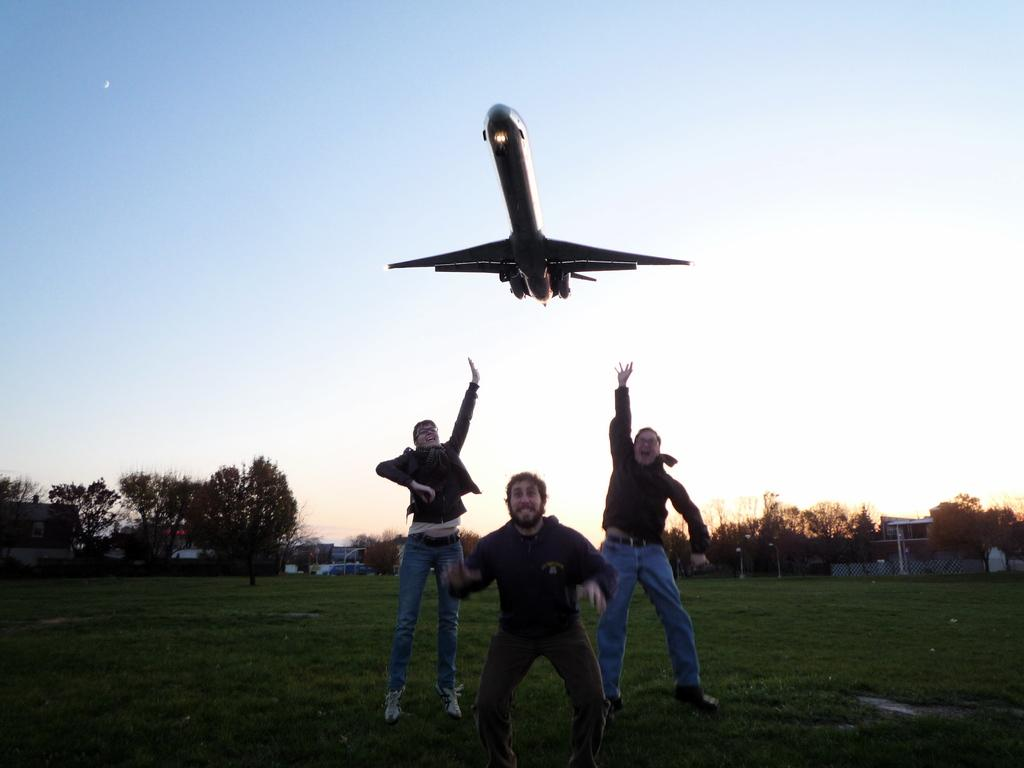How many people are present in the image? There are three persons standing in the image. What can be seen in the background of the image? There are trees and an airplane flying in the sky in the background of the image. What type of story is being told by the zinc in the image? There is no zinc present in the image, and therefore no story can be told by it. 